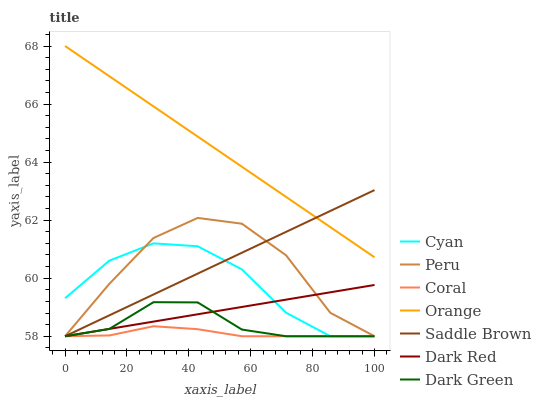Does Coral have the minimum area under the curve?
Answer yes or no. Yes. Does Peru have the minimum area under the curve?
Answer yes or no. No. Does Peru have the maximum area under the curve?
Answer yes or no. No. Is Peru the roughest?
Answer yes or no. Yes. Is Coral the smoothest?
Answer yes or no. No. Is Coral the roughest?
Answer yes or no. No. Does Orange have the lowest value?
Answer yes or no. No. Does Peru have the highest value?
Answer yes or no. No. Is Peru less than Orange?
Answer yes or no. Yes. Is Orange greater than Cyan?
Answer yes or no. Yes. Does Peru intersect Orange?
Answer yes or no. No. 